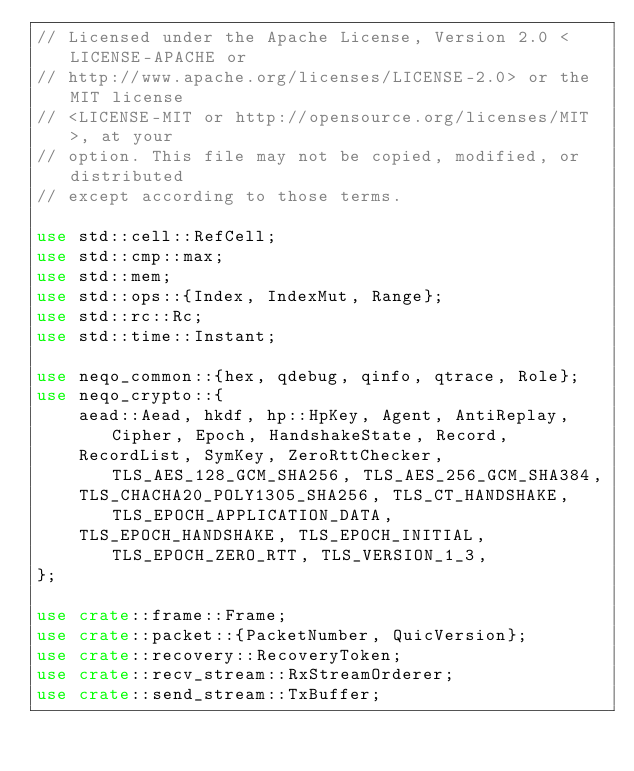<code> <loc_0><loc_0><loc_500><loc_500><_Rust_>// Licensed under the Apache License, Version 2.0 <LICENSE-APACHE or
// http://www.apache.org/licenses/LICENSE-2.0> or the MIT license
// <LICENSE-MIT or http://opensource.org/licenses/MIT>, at your
// option. This file may not be copied, modified, or distributed
// except according to those terms.

use std::cell::RefCell;
use std::cmp::max;
use std::mem;
use std::ops::{Index, IndexMut, Range};
use std::rc::Rc;
use std::time::Instant;

use neqo_common::{hex, qdebug, qinfo, qtrace, Role};
use neqo_crypto::{
    aead::Aead, hkdf, hp::HpKey, Agent, AntiReplay, Cipher, Epoch, HandshakeState, Record,
    RecordList, SymKey, ZeroRttChecker, TLS_AES_128_GCM_SHA256, TLS_AES_256_GCM_SHA384,
    TLS_CHACHA20_POLY1305_SHA256, TLS_CT_HANDSHAKE, TLS_EPOCH_APPLICATION_DATA,
    TLS_EPOCH_HANDSHAKE, TLS_EPOCH_INITIAL, TLS_EPOCH_ZERO_RTT, TLS_VERSION_1_3,
};

use crate::frame::Frame;
use crate::packet::{PacketNumber, QuicVersion};
use crate::recovery::RecoveryToken;
use crate::recv_stream::RxStreamOrderer;
use crate::send_stream::TxBuffer;</code> 